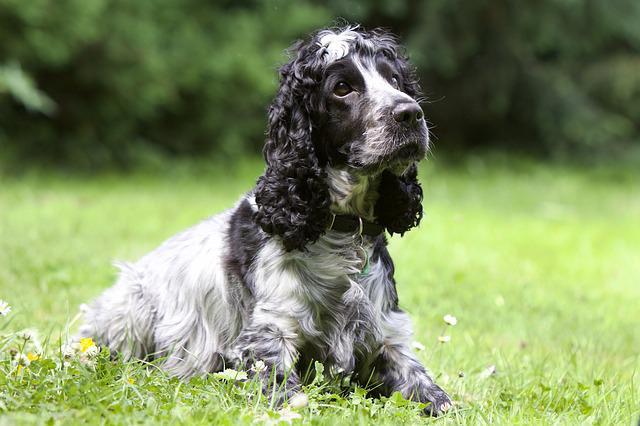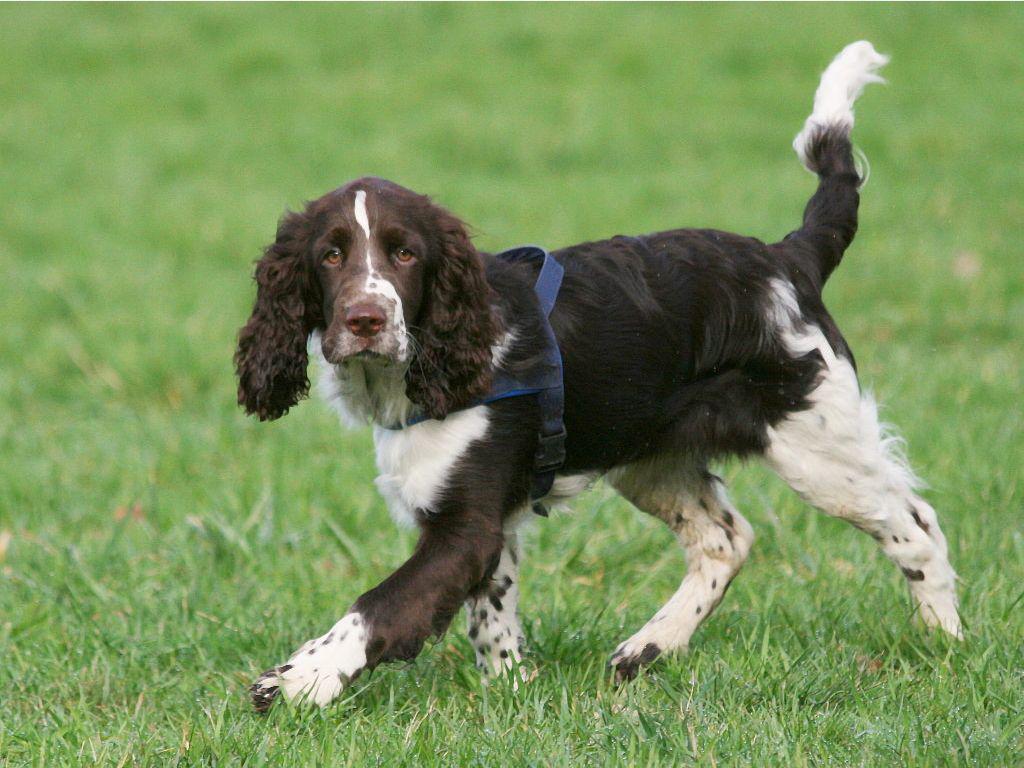The first image is the image on the left, the second image is the image on the right. Evaluate the accuracy of this statement regarding the images: "The dog in the image on the right is on a dirt pathway in the grass.". Is it true? Answer yes or no. No. The first image is the image on the left, the second image is the image on the right. For the images shown, is this caption "The dog in the right image is walking on the grass in profile." true? Answer yes or no. Yes. 